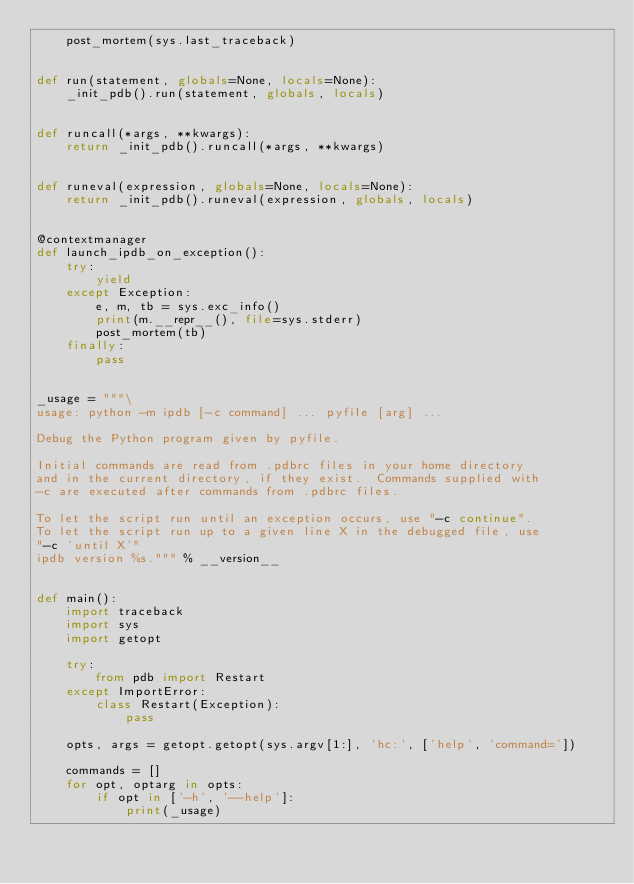<code> <loc_0><loc_0><loc_500><loc_500><_Python_>    post_mortem(sys.last_traceback)


def run(statement, globals=None, locals=None):
    _init_pdb().run(statement, globals, locals)


def runcall(*args, **kwargs):
    return _init_pdb().runcall(*args, **kwargs)


def runeval(expression, globals=None, locals=None):
    return _init_pdb().runeval(expression, globals, locals)


@contextmanager
def launch_ipdb_on_exception():
    try:
        yield
    except Exception:
        e, m, tb = sys.exc_info()
        print(m.__repr__(), file=sys.stderr)
        post_mortem(tb)
    finally:
        pass


_usage = """\
usage: python -m ipdb [-c command] ... pyfile [arg] ...

Debug the Python program given by pyfile.

Initial commands are read from .pdbrc files in your home directory
and in the current directory, if they exist.  Commands supplied with
-c are executed after commands from .pdbrc files.

To let the script run until an exception occurs, use "-c continue".
To let the script run up to a given line X in the debugged file, use
"-c 'until X'"
ipdb version %s.""" % __version__


def main():
    import traceback
    import sys
    import getopt

    try:
        from pdb import Restart
    except ImportError:
        class Restart(Exception):
            pass
    
    opts, args = getopt.getopt(sys.argv[1:], 'hc:', ['help', 'command='])

    commands = []
    for opt, optarg in opts:
        if opt in ['-h', '--help']:
            print(_usage)</code> 